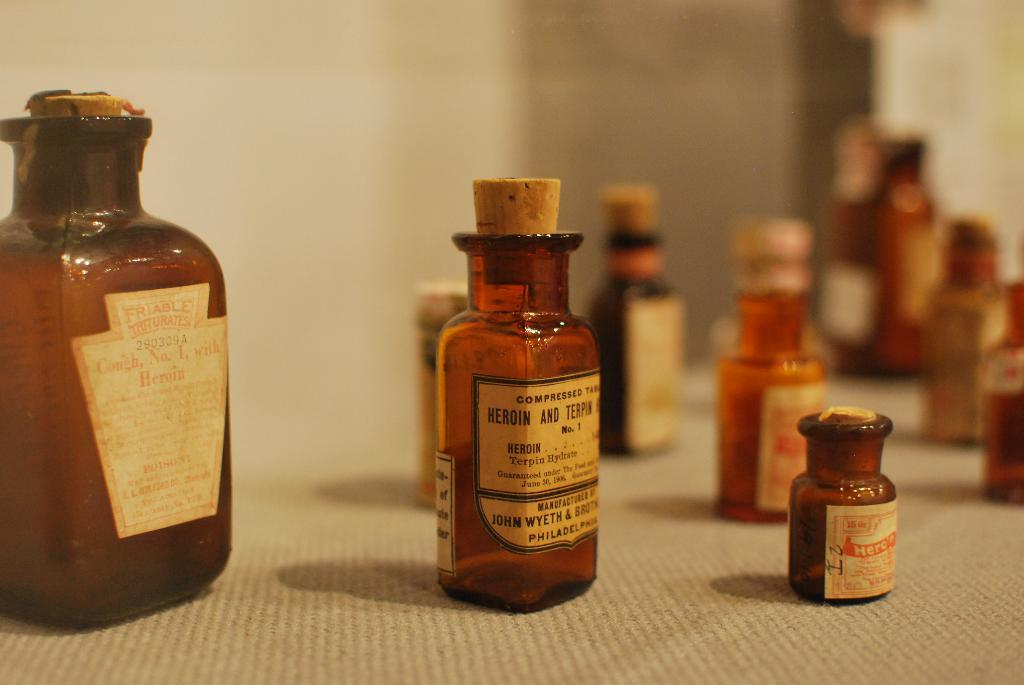<image>
Create a compact narrative representing the image presented. A selection of vintage medicine bottle, one saying: "compressed Heroin and Terpin" 